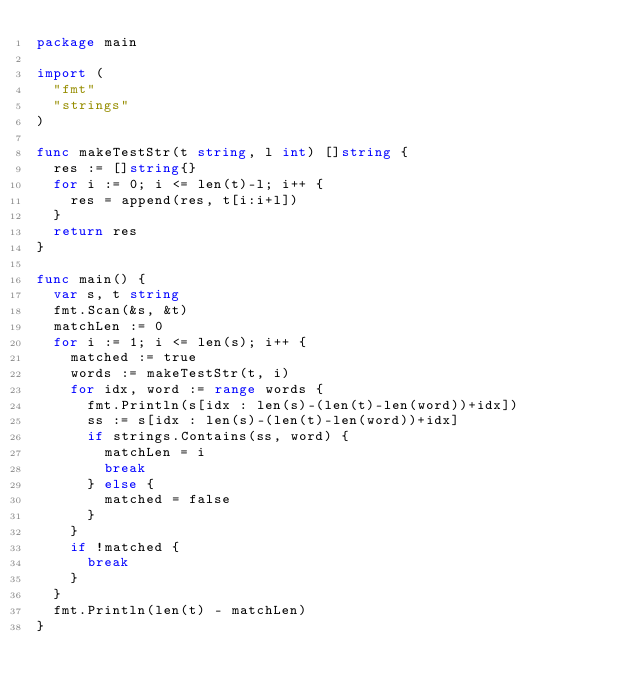Convert code to text. <code><loc_0><loc_0><loc_500><loc_500><_Go_>package main

import (
	"fmt"
	"strings"
)

func makeTestStr(t string, l int) []string {
	res := []string{}
	for i := 0; i <= len(t)-l; i++ {
		res = append(res, t[i:i+l])
	}
	return res
}

func main() {
	var s, t string
	fmt.Scan(&s, &t)
	matchLen := 0
	for i := 1; i <= len(s); i++ {
		matched := true
		words := makeTestStr(t, i)
		for idx, word := range words {
			fmt.Println(s[idx : len(s)-(len(t)-len(word))+idx])
			ss := s[idx : len(s)-(len(t)-len(word))+idx]
			if strings.Contains(ss, word) {
				matchLen = i
				break
			} else {
				matched = false
			}
		}
		if !matched {
			break
		}
	}
	fmt.Println(len(t) - matchLen)
}
</code> 